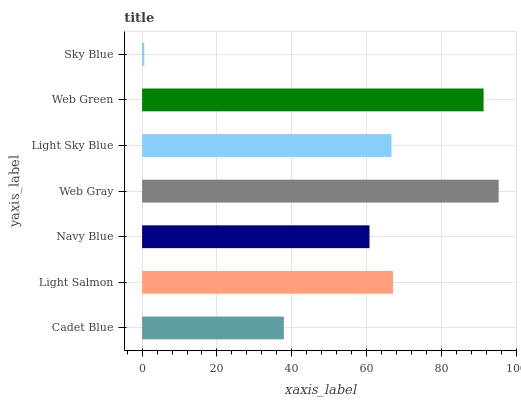Is Sky Blue the minimum?
Answer yes or no. Yes. Is Web Gray the maximum?
Answer yes or no. Yes. Is Light Salmon the minimum?
Answer yes or no. No. Is Light Salmon the maximum?
Answer yes or no. No. Is Light Salmon greater than Cadet Blue?
Answer yes or no. Yes. Is Cadet Blue less than Light Salmon?
Answer yes or no. Yes. Is Cadet Blue greater than Light Salmon?
Answer yes or no. No. Is Light Salmon less than Cadet Blue?
Answer yes or no. No. Is Light Sky Blue the high median?
Answer yes or no. Yes. Is Light Sky Blue the low median?
Answer yes or no. Yes. Is Navy Blue the high median?
Answer yes or no. No. Is Sky Blue the low median?
Answer yes or no. No. 